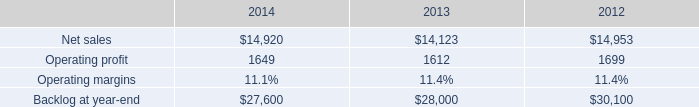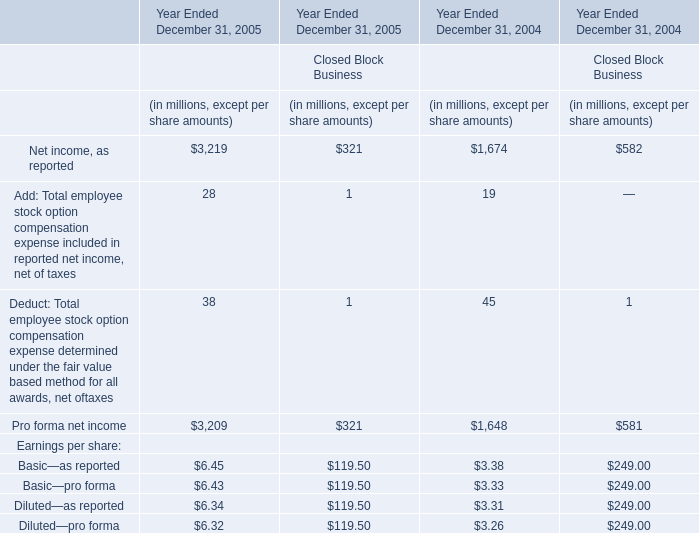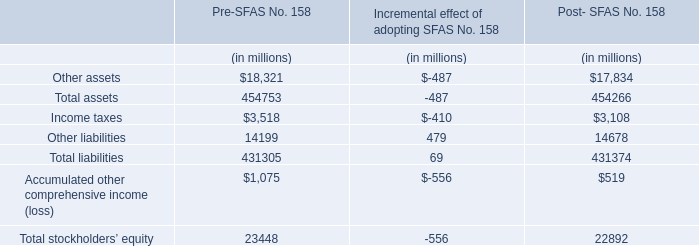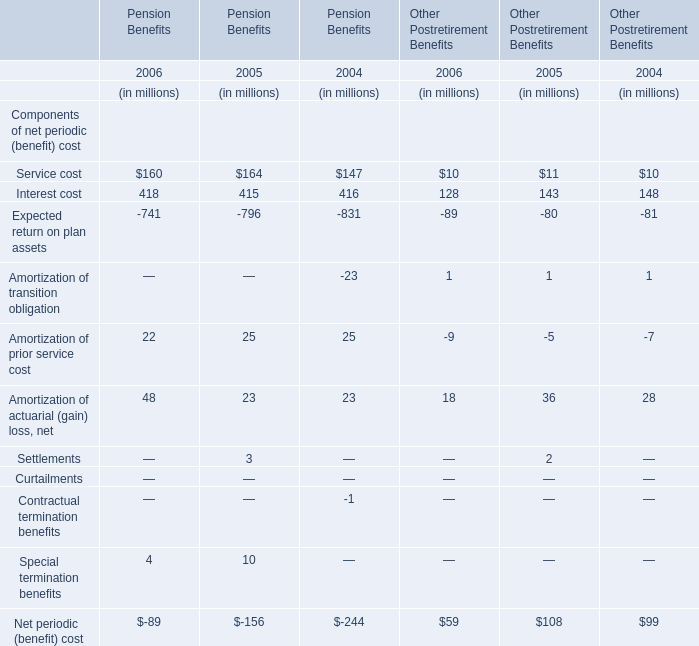what was the percent of the change in the operating profit from 2013 to 2014 
Computations: ((1649 / 1612) / 1612)
Answer: 0.00063. 